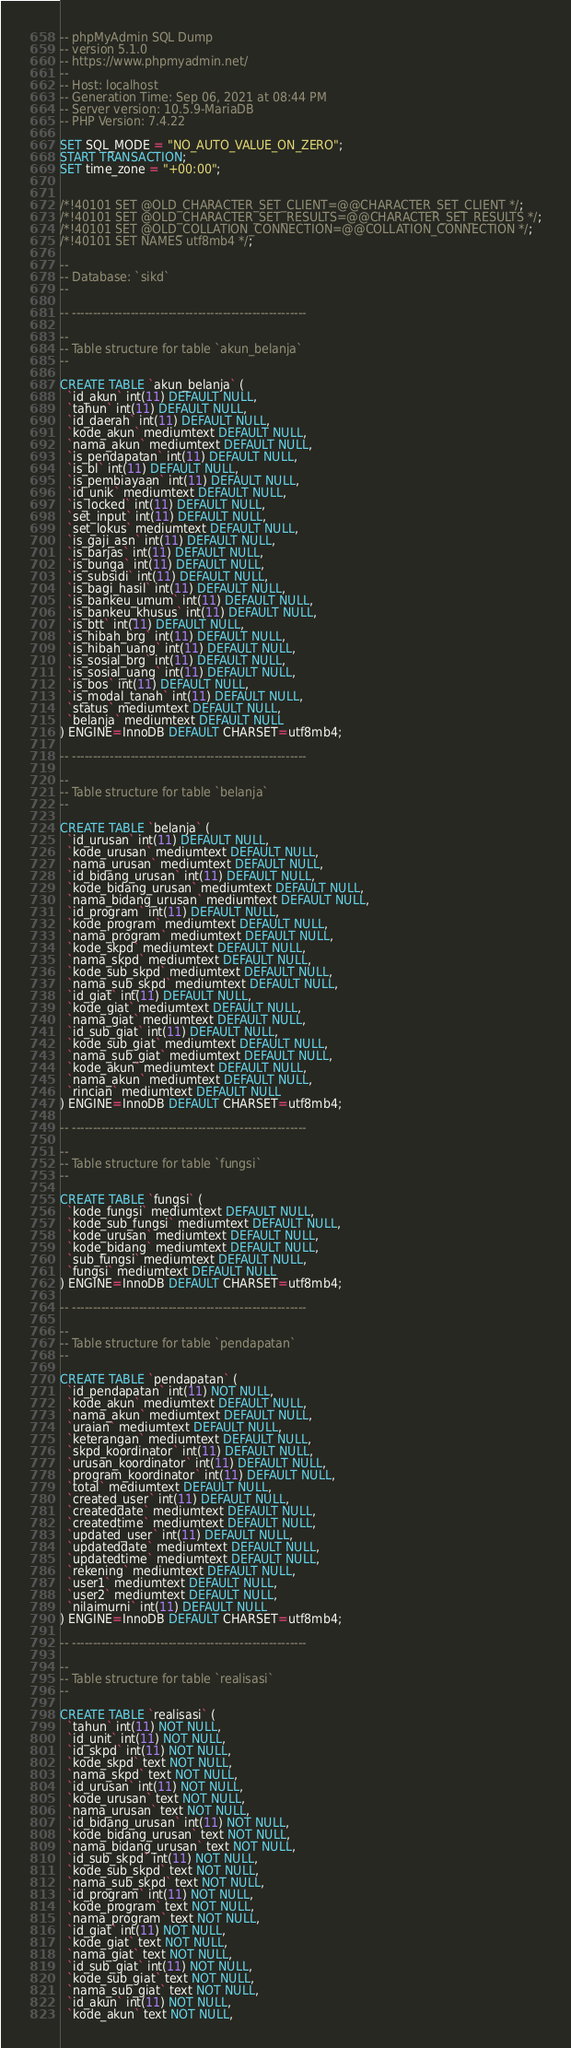Convert code to text. <code><loc_0><loc_0><loc_500><loc_500><_SQL_>-- phpMyAdmin SQL Dump
-- version 5.1.0
-- https://www.phpmyadmin.net/
--
-- Host: localhost
-- Generation Time: Sep 06, 2021 at 08:44 PM
-- Server version: 10.5.9-MariaDB
-- PHP Version: 7.4.22

SET SQL_MODE = "NO_AUTO_VALUE_ON_ZERO";
START TRANSACTION;
SET time_zone = "+00:00";


/*!40101 SET @OLD_CHARACTER_SET_CLIENT=@@CHARACTER_SET_CLIENT */;
/*!40101 SET @OLD_CHARACTER_SET_RESULTS=@@CHARACTER_SET_RESULTS */;
/*!40101 SET @OLD_COLLATION_CONNECTION=@@COLLATION_CONNECTION */;
/*!40101 SET NAMES utf8mb4 */;

--
-- Database: `sikd`
--

-- --------------------------------------------------------

--
-- Table structure for table `akun_belanja`
--

CREATE TABLE `akun_belanja` (
  `id_akun` int(11) DEFAULT NULL,
  `tahun` int(11) DEFAULT NULL,
  `id_daerah` int(11) DEFAULT NULL,
  `kode_akun` mediumtext DEFAULT NULL,
  `nama_akun` mediumtext DEFAULT NULL,
  `is_pendapatan` int(11) DEFAULT NULL,
  `is_bl` int(11) DEFAULT NULL,
  `is_pembiayaan` int(11) DEFAULT NULL,
  `id_unik` mediumtext DEFAULT NULL,
  `is_locked` int(11) DEFAULT NULL,
  `set_input` int(11) DEFAULT NULL,
  `set_lokus` mediumtext DEFAULT NULL,
  `is_gaji_asn` int(11) DEFAULT NULL,
  `is_barjas` int(11) DEFAULT NULL,
  `is_bunga` int(11) DEFAULT NULL,
  `is_subsidi` int(11) DEFAULT NULL,
  `is_bagi_hasil` int(11) DEFAULT NULL,
  `is_bankeu_umum` int(11) DEFAULT NULL,
  `is_bankeu_khusus` int(11) DEFAULT NULL,
  `is_btt` int(11) DEFAULT NULL,
  `is_hibah_brg` int(11) DEFAULT NULL,
  `is_hibah_uang` int(11) DEFAULT NULL,
  `is_sosial_brg` int(11) DEFAULT NULL,
  `is_sosial_uang` int(11) DEFAULT NULL,
  `is_bos` int(11) DEFAULT NULL,
  `is_modal_tanah` int(11) DEFAULT NULL,
  `status` mediumtext DEFAULT NULL,
  `belanja` mediumtext DEFAULT NULL
) ENGINE=InnoDB DEFAULT CHARSET=utf8mb4;

-- --------------------------------------------------------

--
-- Table structure for table `belanja`
--

CREATE TABLE `belanja` (
  `id_urusan` int(11) DEFAULT NULL,
  `kode_urusan` mediumtext DEFAULT NULL,
  `nama_urusan` mediumtext DEFAULT NULL,
  `id_bidang_urusan` int(11) DEFAULT NULL,
  `kode_bidang_urusan` mediumtext DEFAULT NULL,
  `nama_bidang_urusan` mediumtext DEFAULT NULL,
  `id_program` int(11) DEFAULT NULL,
  `kode_program` mediumtext DEFAULT NULL,
  `nama_program` mediumtext DEFAULT NULL,
  `kode_skpd` mediumtext DEFAULT NULL,
  `nama_skpd` mediumtext DEFAULT NULL,
  `kode_sub_skpd` mediumtext DEFAULT NULL,
  `nama_sub_skpd` mediumtext DEFAULT NULL,
  `id_giat` int(11) DEFAULT NULL,
  `kode_giat` mediumtext DEFAULT NULL,
  `nama_giat` mediumtext DEFAULT NULL,
  `id_sub_giat` int(11) DEFAULT NULL,
  `kode_sub_giat` mediumtext DEFAULT NULL,
  `nama_sub_giat` mediumtext DEFAULT NULL,
  `kode_akun` mediumtext DEFAULT NULL,
  `nama_akun` mediumtext DEFAULT NULL,
  `rincian` mediumtext DEFAULT NULL
) ENGINE=InnoDB DEFAULT CHARSET=utf8mb4;

-- --------------------------------------------------------

--
-- Table structure for table `fungsi`
--

CREATE TABLE `fungsi` (
  `kode_fungsi` mediumtext DEFAULT NULL,
  `kode_sub_fungsi` mediumtext DEFAULT NULL,
  `kode_urusan` mediumtext DEFAULT NULL,
  `kode_bidang` mediumtext DEFAULT NULL,
  `sub_fungsi` mediumtext DEFAULT NULL,
  `fungsi` mediumtext DEFAULT NULL
) ENGINE=InnoDB DEFAULT CHARSET=utf8mb4;

-- --------------------------------------------------------

--
-- Table structure for table `pendapatan`
--

CREATE TABLE `pendapatan` (
  `id_pendapatan` int(11) NOT NULL,
  `kode_akun` mediumtext DEFAULT NULL,
  `nama_akun` mediumtext DEFAULT NULL,
  `uraian` mediumtext DEFAULT NULL,
  `keterangan` mediumtext DEFAULT NULL,
  `skpd_koordinator` int(11) DEFAULT NULL,
  `urusan_koordinator` int(11) DEFAULT NULL,
  `program_koordinator` int(11) DEFAULT NULL,
  `total` mediumtext DEFAULT NULL,
  `created_user` int(11) DEFAULT NULL,
  `createddate` mediumtext DEFAULT NULL,
  `createdtime` mediumtext DEFAULT NULL,
  `updated_user` int(11) DEFAULT NULL,
  `updateddate` mediumtext DEFAULT NULL,
  `updatedtime` mediumtext DEFAULT NULL,
  `rekening` mediumtext DEFAULT NULL,
  `user1` mediumtext DEFAULT NULL,
  `user2` mediumtext DEFAULT NULL,
  `nilaimurni` int(11) DEFAULT NULL
) ENGINE=InnoDB DEFAULT CHARSET=utf8mb4;

-- --------------------------------------------------------

--
-- Table structure for table `realisasi`
--

CREATE TABLE `realisasi` (
  `tahun` int(11) NOT NULL,
  `id_unit` int(11) NOT NULL,
  `id_skpd` int(11) NOT NULL,
  `kode_skpd` text NOT NULL,
  `nama_skpd` text NOT NULL,
  `id_urusan` int(11) NOT NULL,
  `kode_urusan` text NOT NULL,
  `nama_urusan` text NOT NULL,
  `id_bidang_urusan` int(11) NOT NULL,
  `kode_bidang_urusan` text NOT NULL,
  `nama_bidang_urusan` text NOT NULL,
  `id_sub_skpd` int(11) NOT NULL,
  `kode_sub_skpd` text NOT NULL,
  `nama_sub_skpd` text NOT NULL,
  `id_program` int(11) NOT NULL,
  `kode_program` text NOT NULL,
  `nama_program` text NOT NULL,
  `id_giat` int(11) NOT NULL,
  `kode_giat` text NOT NULL,
  `nama_giat` text NOT NULL,
  `id_sub_giat` int(11) NOT NULL,
  `kode_sub_giat` text NOT NULL,
  `nama_sub_giat` text NOT NULL,
  `id_akun` int(11) NOT NULL,
  `kode_akun` text NOT NULL,</code> 